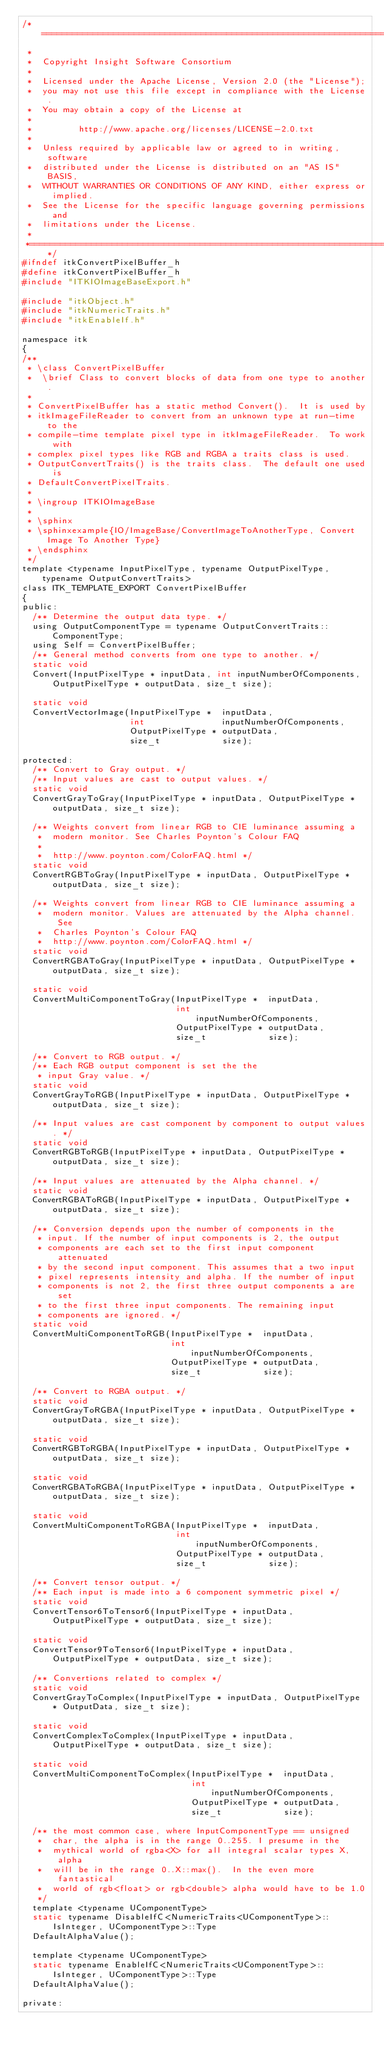Convert code to text. <code><loc_0><loc_0><loc_500><loc_500><_C_>/*=========================================================================
 *
 *  Copyright Insight Software Consortium
 *
 *  Licensed under the Apache License, Version 2.0 (the "License");
 *  you may not use this file except in compliance with the License.
 *  You may obtain a copy of the License at
 *
 *         http://www.apache.org/licenses/LICENSE-2.0.txt
 *
 *  Unless required by applicable law or agreed to in writing, software
 *  distributed under the License is distributed on an "AS IS" BASIS,
 *  WITHOUT WARRANTIES OR CONDITIONS OF ANY KIND, either express or implied.
 *  See the License for the specific language governing permissions and
 *  limitations under the License.
 *
 *=========================================================================*/
#ifndef itkConvertPixelBuffer_h
#define itkConvertPixelBuffer_h
#include "ITKIOImageBaseExport.h"

#include "itkObject.h"
#include "itkNumericTraits.h"
#include "itkEnableIf.h"

namespace itk
{
/**
 * \class ConvertPixelBuffer
 *  \brief Class to convert blocks of data from one type to another.
 *
 * ConvertPixelBuffer has a static method Convert().  It is used by
 * itkImageFileReader to convert from an unknown type at run-time to the
 * compile-time template pixel type in itkImageFileReader.  To work with
 * complex pixel types like RGB and RGBA a traits class is used.
 * OutputConvertTraits() is the traits class.  The default one used is
 * DefaultConvertPixelTraits.
 *
 * \ingroup ITKIOImageBase
 *
 * \sphinx
 * \sphinxexample{IO/ImageBase/ConvertImageToAnotherType, Convert Image To Another Type}
 * \endsphinx
 */
template <typename InputPixelType, typename OutputPixelType, typename OutputConvertTraits>
class ITK_TEMPLATE_EXPORT ConvertPixelBuffer
{
public:
  /** Determine the output data type. */
  using OutputComponentType = typename OutputConvertTraits::ComponentType;
  using Self = ConvertPixelBuffer;
  /** General method converts from one type to another. */
  static void
  Convert(InputPixelType * inputData, int inputNumberOfComponents, OutputPixelType * outputData, size_t size);

  static void
  ConvertVectorImage(InputPixelType *  inputData,
                     int               inputNumberOfComponents,
                     OutputPixelType * outputData,
                     size_t            size);

protected:
  /** Convert to Gray output. */
  /** Input values are cast to output values. */
  static void
  ConvertGrayToGray(InputPixelType * inputData, OutputPixelType * outputData, size_t size);

  /** Weights convert from linear RGB to CIE luminance assuming a
   *  modern monitor. See Charles Poynton's Colour FAQ
   *
   *  http://www.poynton.com/ColorFAQ.html */
  static void
  ConvertRGBToGray(InputPixelType * inputData, OutputPixelType * outputData, size_t size);

  /** Weights convert from linear RGB to CIE luminance assuming a
   *  modern monitor. Values are attenuated by the Alpha channel. See
   *  Charles Poynton's Colour FAQ
   *  http://www.poynton.com/ColorFAQ.html */
  static void
  ConvertRGBAToGray(InputPixelType * inputData, OutputPixelType * outputData, size_t size);

  static void
  ConvertMultiComponentToGray(InputPixelType *  inputData,
                              int               inputNumberOfComponents,
                              OutputPixelType * outputData,
                              size_t            size);

  /** Convert to RGB output. */
  /** Each RGB output component is set the the
   * input Gray value. */
  static void
  ConvertGrayToRGB(InputPixelType * inputData, OutputPixelType * outputData, size_t size);

  /** Input values are cast component by component to output values. */
  static void
  ConvertRGBToRGB(InputPixelType * inputData, OutputPixelType * outputData, size_t size);

  /** Input values are attenuated by the Alpha channel. */
  static void
  ConvertRGBAToRGB(InputPixelType * inputData, OutputPixelType * outputData, size_t size);

  /** Conversion depends upon the number of components in the
   * input. If the number of input components is 2, the output
   * components are each set to the first input component attenuated
   * by the second input component. This assumes that a two input
   * pixel represents intensity and alpha. If the number of input
   * components is not 2, the first three output components a are set
   * to the first three input components. The remaining input
   * components are ignored. */
  static void
  ConvertMultiComponentToRGB(InputPixelType *  inputData,
                             int               inputNumberOfComponents,
                             OutputPixelType * outputData,
                             size_t            size);

  /** Convert to RGBA output. */
  static void
  ConvertGrayToRGBA(InputPixelType * inputData, OutputPixelType * outputData, size_t size);

  static void
  ConvertRGBToRGBA(InputPixelType * inputData, OutputPixelType * outputData, size_t size);

  static void
  ConvertRGBAToRGBA(InputPixelType * inputData, OutputPixelType * outputData, size_t size);

  static void
  ConvertMultiComponentToRGBA(InputPixelType *  inputData,
                              int               inputNumberOfComponents,
                              OutputPixelType * outputData,
                              size_t            size);

  /** Convert tensor output. */
  /** Each input is made into a 6 component symmetric pixel */
  static void
  ConvertTensor6ToTensor6(InputPixelType * inputData, OutputPixelType * outputData, size_t size);

  static void
  ConvertTensor9ToTensor6(InputPixelType * inputData, OutputPixelType * outputData, size_t size);

  /** Convertions related to complex */
  static void
  ConvertGrayToComplex(InputPixelType * inputData, OutputPixelType * OutputData, size_t size);

  static void
  ConvertComplexToComplex(InputPixelType * inputData, OutputPixelType * outputData, size_t size);

  static void
  ConvertMultiComponentToComplex(InputPixelType *  inputData,
                                 int               inputNumberOfComponents,
                                 OutputPixelType * outputData,
                                 size_t            size);

  /** the most common case, where InputComponentType == unsigned
   *  char, the alpha is in the range 0..255. I presume in the
   *  mythical world of rgba<X> for all integral scalar types X, alpha
   *  will be in the range 0..X::max().  In the even more fantastical
   *  world of rgb<float> or rgb<double> alpha would have to be 1.0
   */
  template <typename UComponentType>
  static typename DisableIfC<NumericTraits<UComponentType>::IsInteger, UComponentType>::Type
  DefaultAlphaValue();

  template <typename UComponentType>
  static typename EnableIfC<NumericTraits<UComponentType>::IsInteger, UComponentType>::Type
  DefaultAlphaValue();

private:</code> 